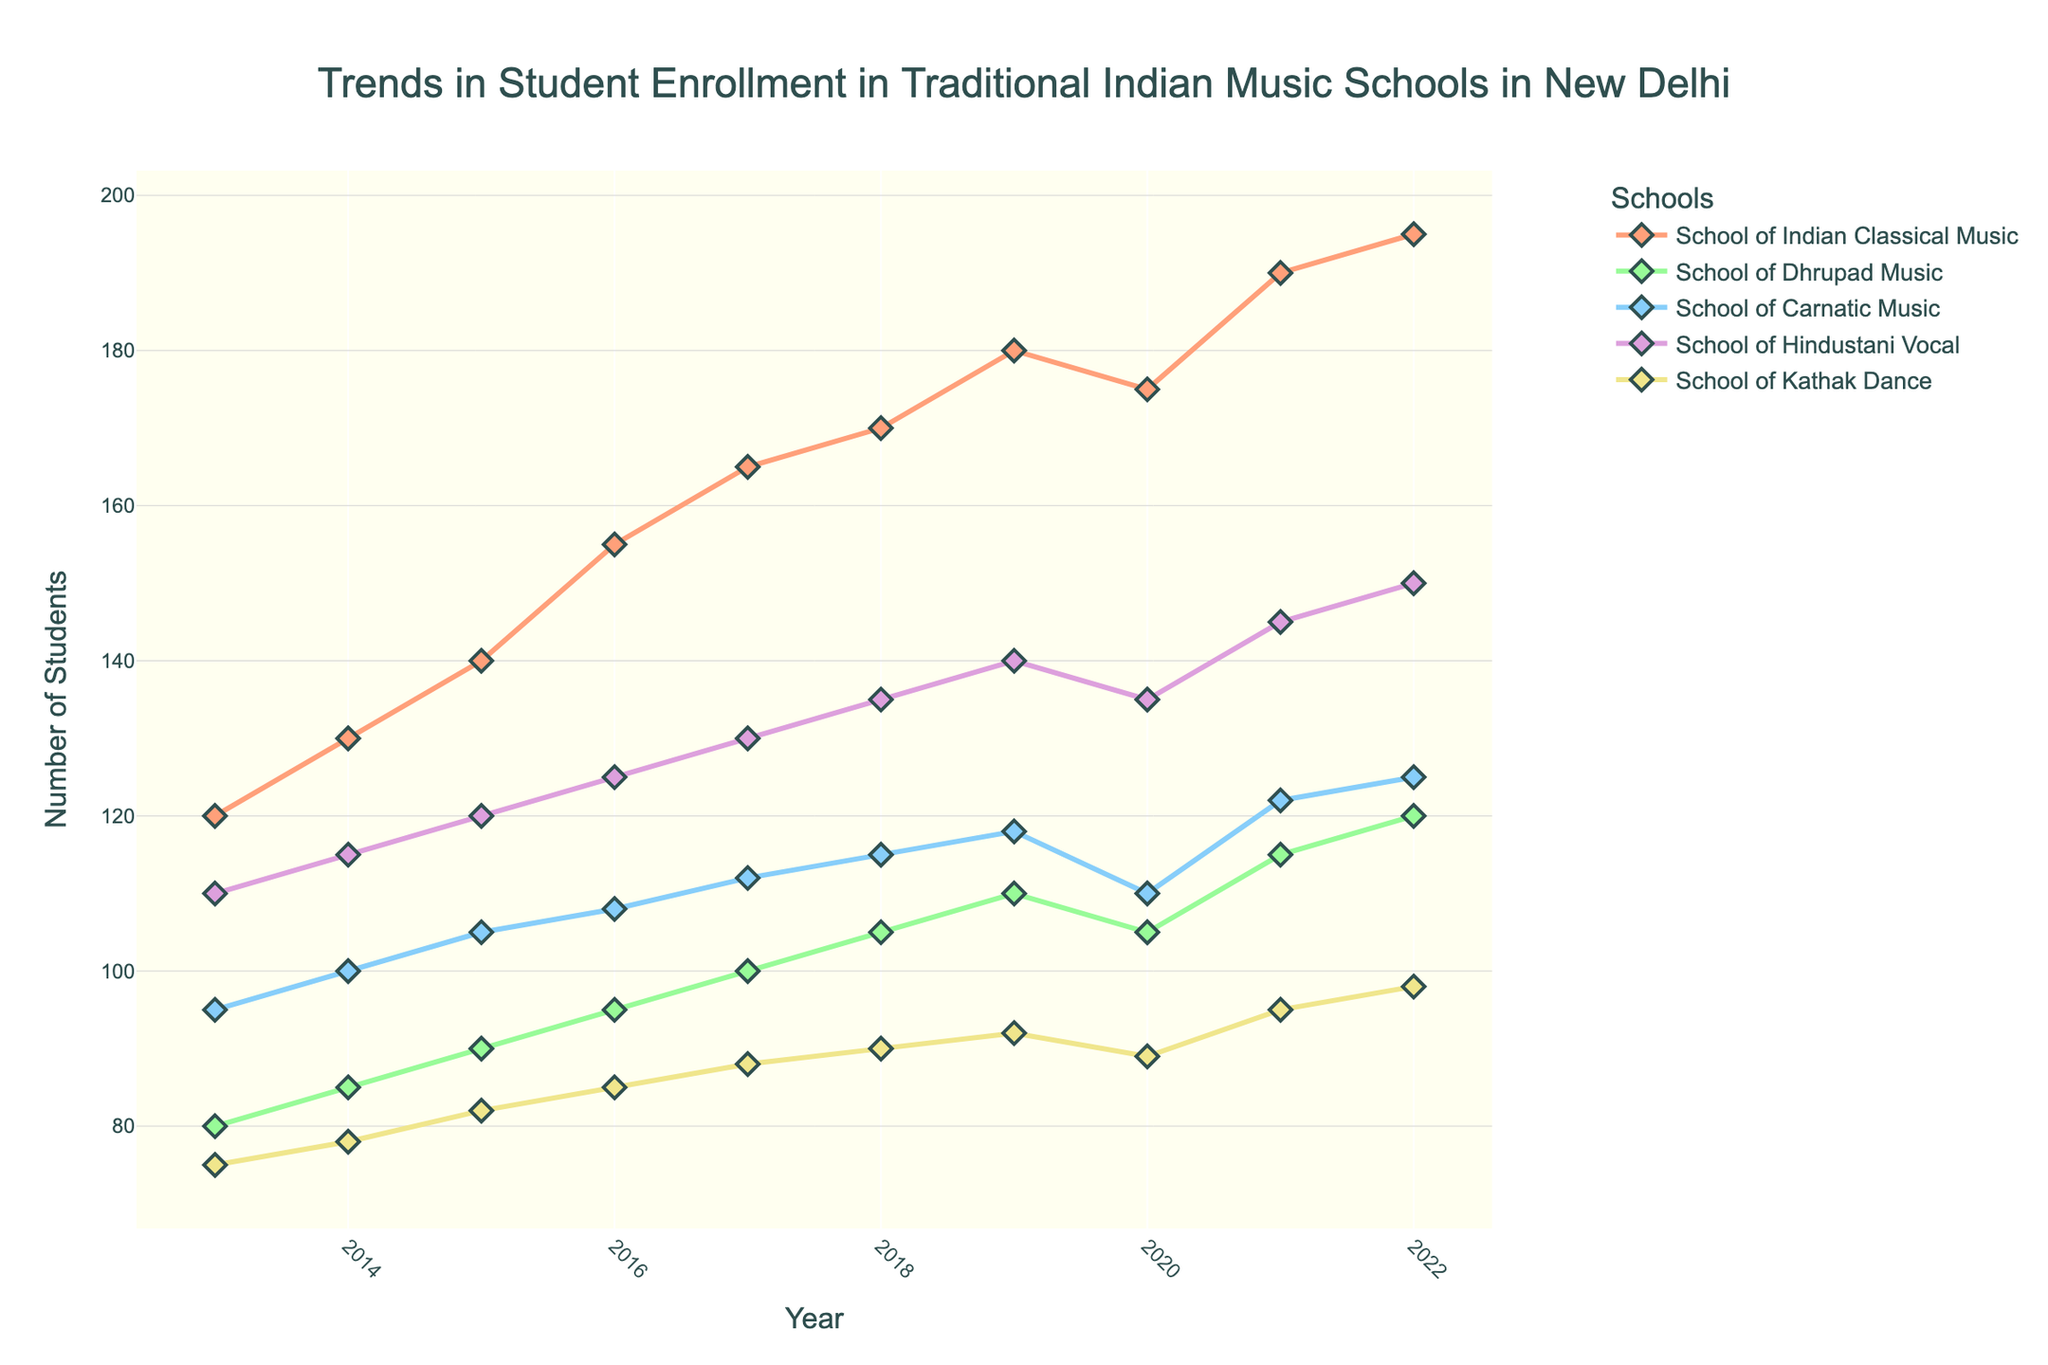What is the title of the plot? The title of the plot is usually located at the top center of the figure, and it provides an overall summary of the plotted data.
Answer: Trends in Student Enrollment in Traditional Indian Music Schools in New Delhi How many schools are being compared in the plot? By counting the number of different lines or entries in the legend, one can determine the number of distinct schools represented in the plot. The figure shows a legend listing all the schools.
Answer: 5 Which school had the highest enrollment in 2020? To find this, examine the data points corresponding to 2020 on the x-axis for all the schools and identify the one with the highest y-value.
Answer: School of Hindustani Vocal What is the overall trend in student enrollment for the School of Dhrupad Music from 2013 to 2022? By looking at the line representing the School of Dhrupad Music and observing the y-values over the years, we can determine the trend. The data shows a consistent increase.
Answer: Increasing Which school experienced a drop in enrollment between 2019 and 2020? Identify the data points for 2019 and 2020 for each school and look for any decrease in y-values between these years.
Answer: School of Indian Classical Music What was the average enrollment across all schools in 2017? Sum the enrollments of all the schools for the year 2017 and divide by the number of schools to get the average.
Answer: (165 + 100 + 112 + 130 + 88) / 5 = 119 Which school showed the most consistent growth in enrollment over the years? By comparing the smoothness and steadiness of the increasing trend of the lines representing each school, you can identify the one with the most consistent growth.
Answer: School of Carnatic Music How much did the enrollment for the School of Kathak Dance increase from 2013 to 2022? Subtract the 2013 enrollment from the 2022 enrollment for the School of Kathak Dance to find the increase.
Answer: 98 - 75 = 23 In which year did the School of Hindustani Vocal reach 145 students? Locate the data point for the School of Hindustani Vocal that reaches the y-value of 145 and find the corresponding x-axis year.
Answer: 2021 